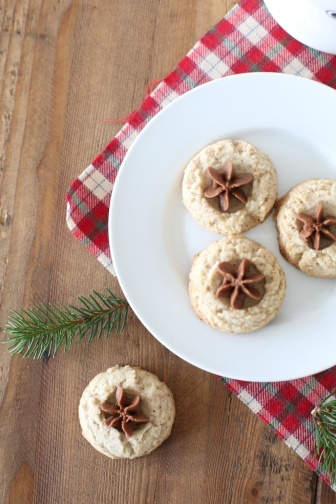Describe the following image. The image presents a homely holiday scene on a rustic wooden surface. In the spotlight is a white, circular plate holding three delectable cookies, each tastefully adorned with a whole star anise at its center. The plate rests on a festive red and white checkered napkin—a classic pattern that often evokes feelings of warmth and seasonal cheer. 

Apart from its companions, a fourth cookie lies directly on the table reinforcing the casual, inviting ambiance. Nearby, a fresh sprig of greenery lends a touch of natural color that beautifully contrasts with the red hues from the napkin and complements the earthy tones of the background and cookies.

The entire arrangement suggests a scene of culinary delight during a holiday gathering, perhaps in preparation for an event or as a personal indulgence. The balance of colors, textures, and items within the frame is a visual invitation to the viewer to partake in the seasonal joy and tasteful elegance. 